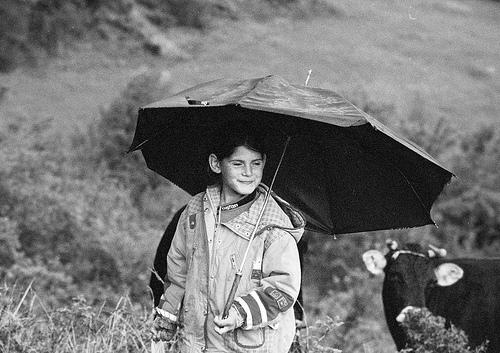What are the essential components of the image and what're the subjects interacting with? The crucial components include a gleeful boy in a raincoat, holding an umbrella and a black cow with white ears; they are interacting with each other in a grassy field. Create a scene presented in the picture, mentioning the objects and their characteristics. In a backdrop of grass and bushes, there is a delighted boy in a raincoat with a plaid patterned inner hood carrying an umbrella, standing beside a black cow with distinctive white ears. Describe what is happening in the image, focusing on the main subjects and the environment. A contented boy wearing a raincoat with a plaid design on the hood holds an umbrella in one hand and stands next to a black cow with white ears, amid a lush, verdant field. Mention the primary elements in the picture and their actions. A boy with joyous expression is wearing a raincoat and holding an umbrella, while a black cow with white ears stands beside him in a grassy field. Summarize the key aspects of the picture in one sentence. A cheerful boy in a plaid raincoat holds an umbrella beside a black cow with white ears in a grassy field. Enumerate the main objects in the image and describe their characteristics. 1. Boy: Happy expression, wearing raincoat with plaid hood, holding umbrella. 2. Cow: Black with white ears, standing nearby. 3. Field: Grass and bushes. Write a brief account of the image, highlighting the important elements. The image showcases a joyful young boy clad in a plaid raincoat, gripping an umbrella, in the company of a black cow with striking white ears, set against a leafy, grassy field. Write a short story based on the situation in the image. On a rainy day, Sam was playing in the field wearing his favorite plaid raincoat and holding an umbrella. He made friends with a black cow that had white ears and they posed for a memorable picture together. Briefly narrate the scene portrayed in the image. A happy boy donning a raincoat with a plaid patterned hood is holding an umbrella next to a cow with white ears in a field of tall grass and bushes. Identify the two main subjects in the image and describe their features and surrounding. The boy has a happy face, wears a raincoat with a plaid patterned hood and holds an umbrella, while the cow alongside him is black with white ears; they are in a field with grass and bushes. 